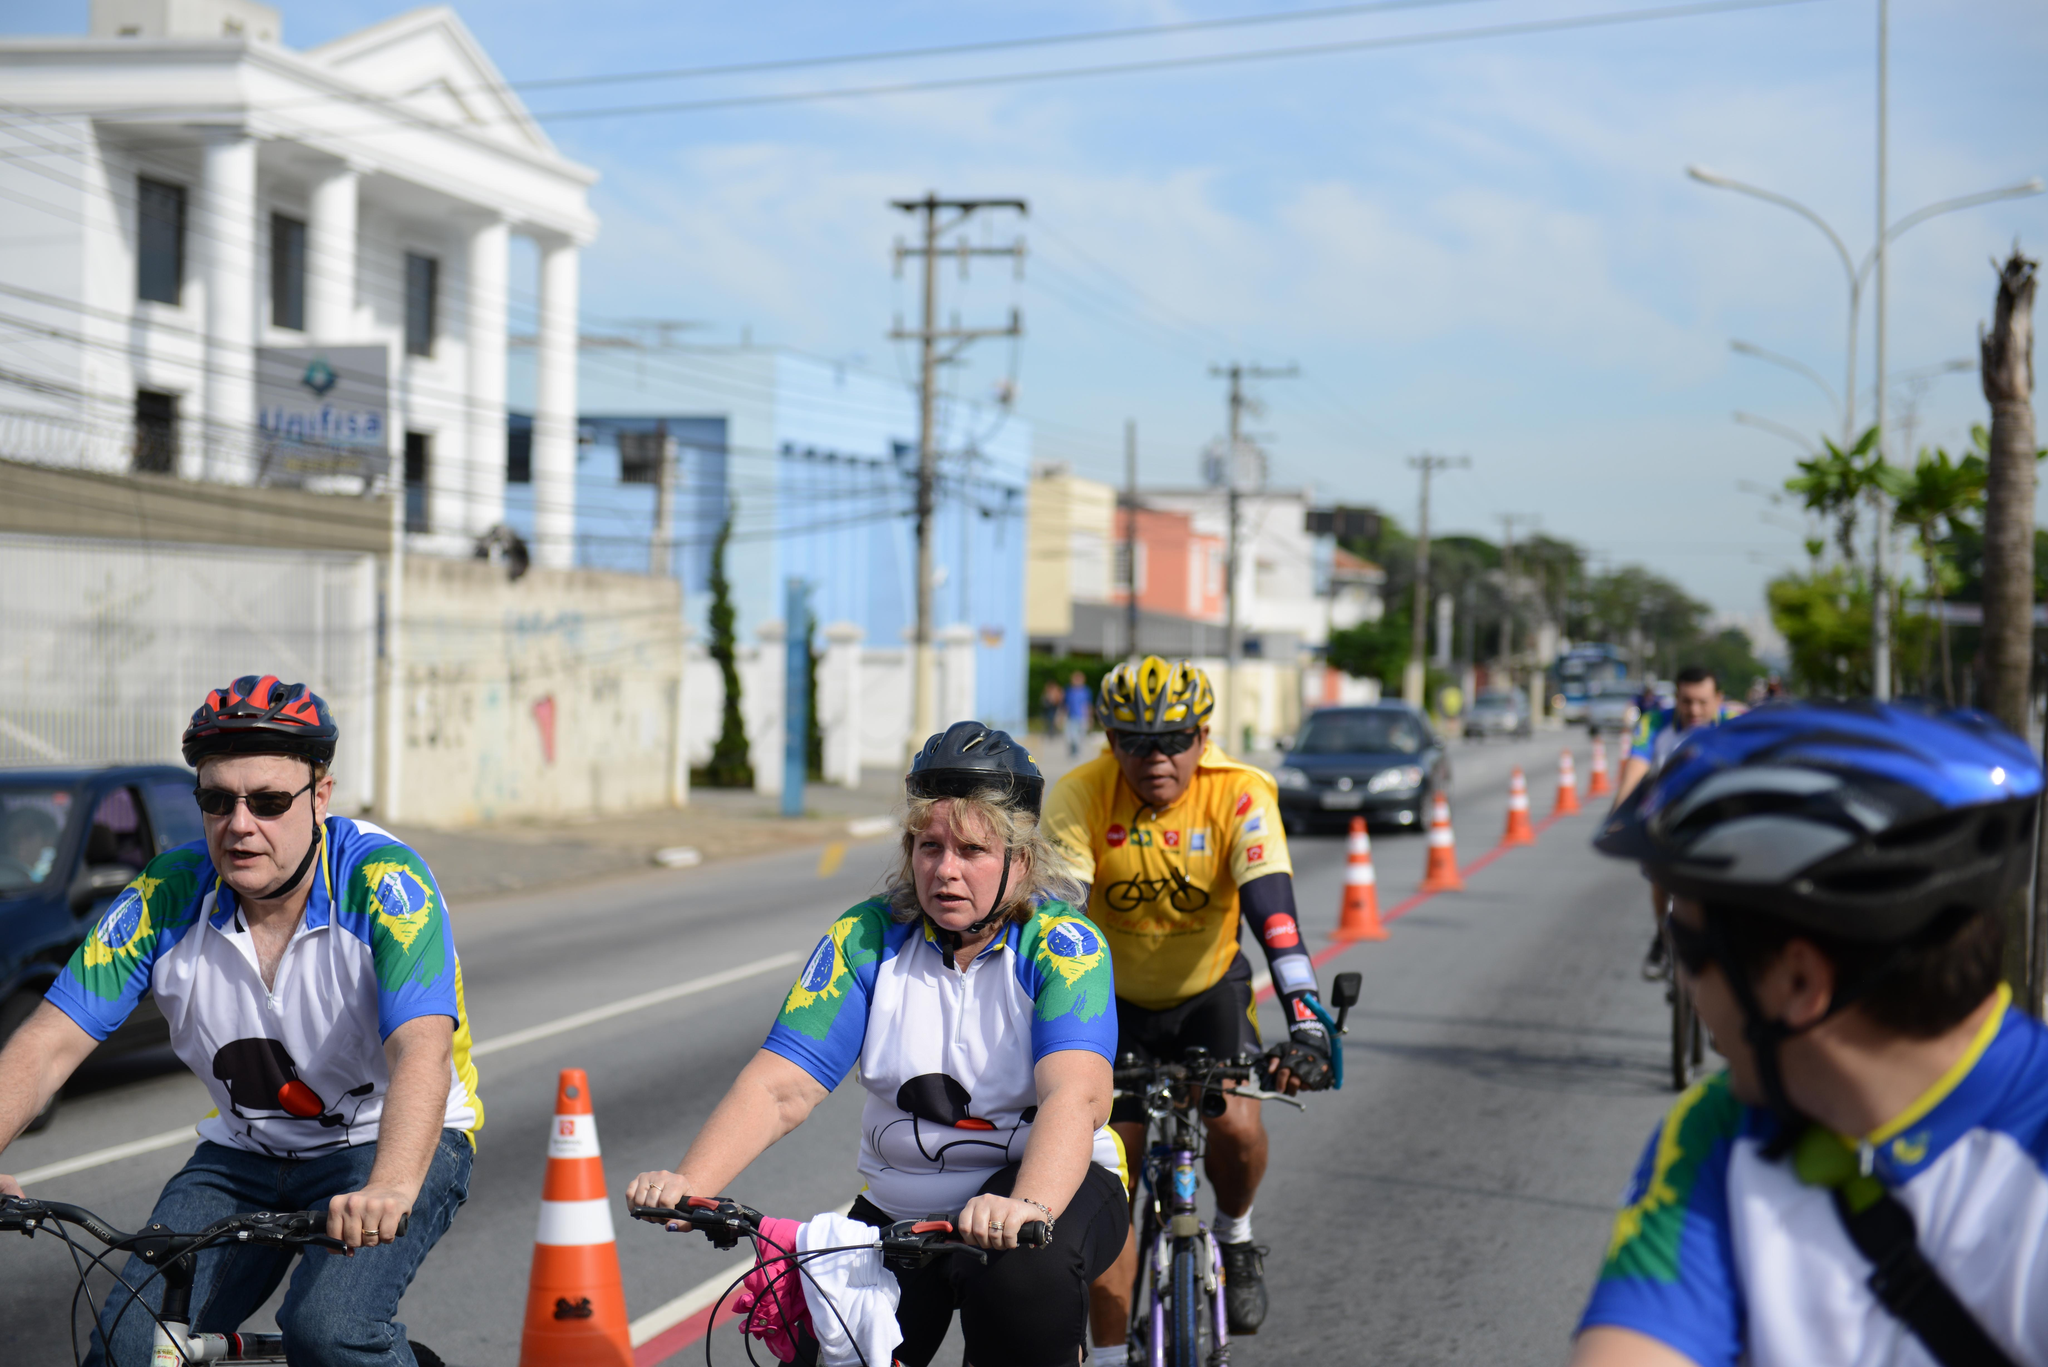What are the people in the image doing? The people in the image are riding bicycles. Where are the bicycles located? The bicycles are in the street. What can be seen in the background of the image? There are buildings, poles, trees, cars, and the sky visible in the background of the image. What is the condition of the sky in the image? A: The sky is covered with clouds in the image. What type of thread is being used to hold the hands of the people riding bicycles in the image? There is no thread present in the image, and the people riding bicycles are not holding hands. 